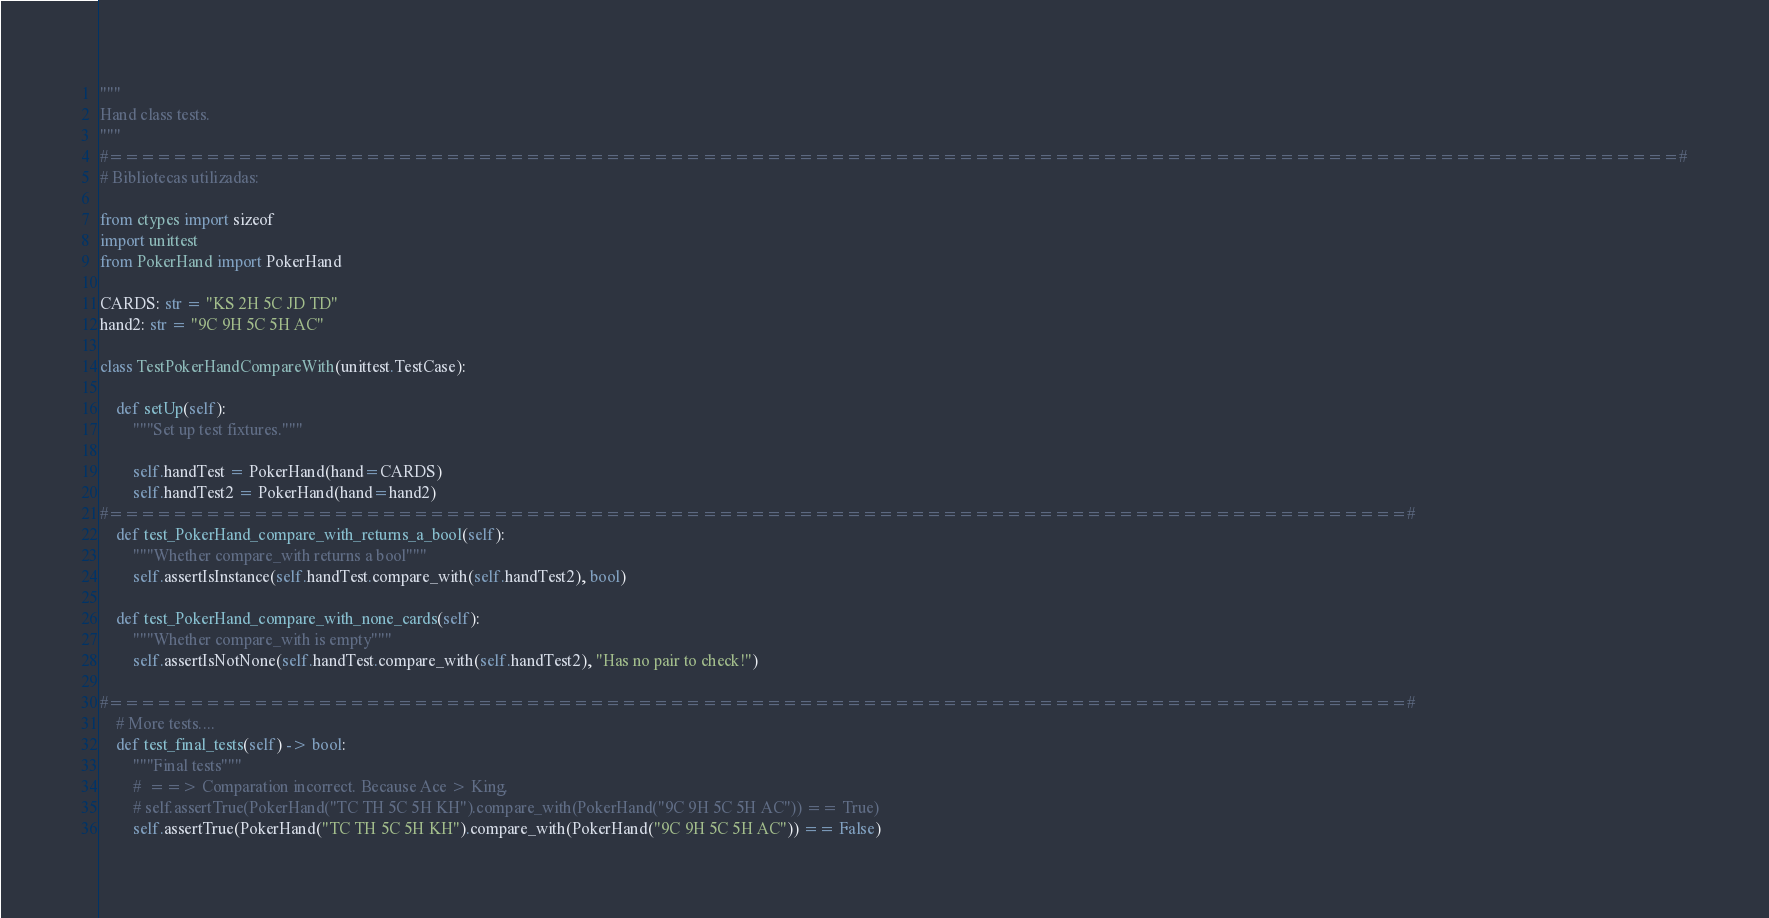<code> <loc_0><loc_0><loc_500><loc_500><_Python_>"""
Hand class tests.    
"""
#==================================================================================================#
# Bibliotecas utilizadas:

from ctypes import sizeof
import unittest
from PokerHand import PokerHand

CARDS: str = "KS 2H 5C JD TD"
hand2: str = "9C 9H 5C 5H AC"

class TestPokerHandCompareWith(unittest.TestCase):
    
    def setUp(self):
        """Set up test fixtures."""
        
        self.handTest = PokerHand(hand=CARDS)
        self.handTest2 = PokerHand(hand=hand2)
#=================================================================================#        
    def test_PokerHand_compare_with_returns_a_bool(self):
        """Whether compare_with returns a bool"""    
        self.assertIsInstance(self.handTest.compare_with(self.handTest2), bool)

    def test_PokerHand_compare_with_none_cards(self):
        """Whether compare_with is empty"""  
        self.assertIsNotNone(self.handTest.compare_with(self.handTest2), "Has no pair to check!")
        
#=================================================================================#
    # More tests....
    def test_final_tests(self) -> bool:
        """Final tests"""
        #  ==> Comparation incorrect. Because Ace > King.
        # self.assertTrue(PokerHand("TC TH 5C 5H KH").compare_with(PokerHand("9C 9H 5C 5H AC")) == True)
        self.assertTrue(PokerHand("TC TH 5C 5H KH").compare_with(PokerHand("9C 9H 5C 5H AC")) == False)</code> 